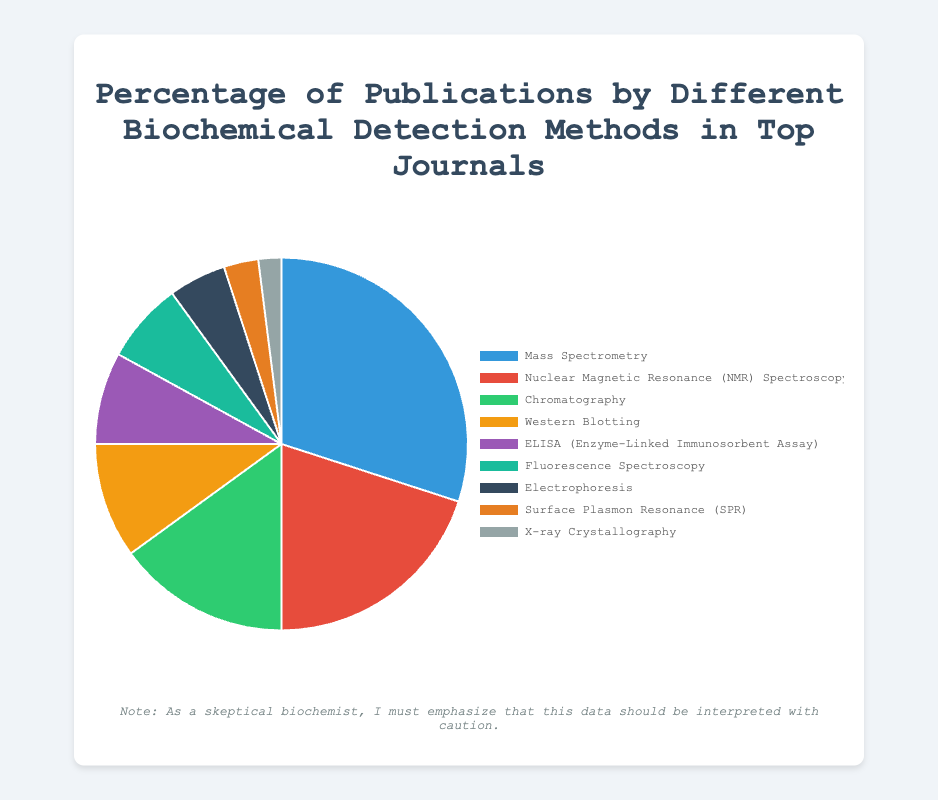Which biochemical detection method has the highest percentage of publications? To determine which method has the highest percentage, refer to the pie chart and identify the largest segment. Here, the largest segment corresponds to Mass Spectrometry.
Answer: Mass Spectrometry What is the combined percentage of publications for Electrophoresis and Surface Plasmon Resonance (SPR)? Add the percentages of Electrophoresis and SPR: 5% + 3% = 8%.
Answer: 8% Which detection method is more popular, Chromatography or Western Blotting? Compare the percentages of Chromatography (15%) and Western Blotting (10%). Since 15% is greater than 10%, Chromatography is more popular.
Answer: Chromatography What is the total percentage of publications for methods with less than 10% each? Add the percentages of Western Blotting (10%), ELISA (8%), Fluorescence Spectroscopy (7%), Electrophoresis (5%), SPR (3%), and X-ray Crystallography (2%): 10% + 8% + 7% + 5% + 3% + 2% = 35%.
Answer: 35% Which method has a larger share, NMR Spectroscopy or ELISA? Compare the percentages of NMR Spectroscopy (20%) and ELISA (8%). Since 20% is greater than 8%, NMR Spectroscopy has a larger share.
Answer: NMR Spectroscopy What is the difference in percentage points between the method with the highest and the method with the lowest publications? Subtract the percentage of the method with the lowest publications (X-ray Crystallography, 2%) from the percentage of the method with the highest publications (Mass Spectrometry, 30%): 30% - 2% = 28%.
Answer: 28% Which segment is represented by the color blue? Since we need to identify the segment represented by the color blue, reference the color information in the explanation. Here, Mass Spectrometry is represented by blue.
Answer: Mass Spectrometry How many methods account for more than 10% of the publications? Identify all methods with more than 10%: Mass Spectrometry (30%), NMR Spectroscopy (20%), and Chromatography (15%). There are 3 methods.
Answer: 3 What is the average percentage of publications for the listed detection methods? Sum all given percentages and then divide by the number of methods: (30% + 20% + 15% + 10% + 8% + 7% + 5% + 3% + 2%) / 9 = 100% / 9 ≈ 11.11%.
Answer: 11.11% Does ELISA contribute more to the publications than Western Blotting and Electrophoresis combined? Compare ELISA’s percentage (8%) to the sum of Western Blotting (10%) and Electrophoresis (5%): 10% + 5% = 15%. Since 8% is less than 15%, ELISA contributes less.
Answer: No 